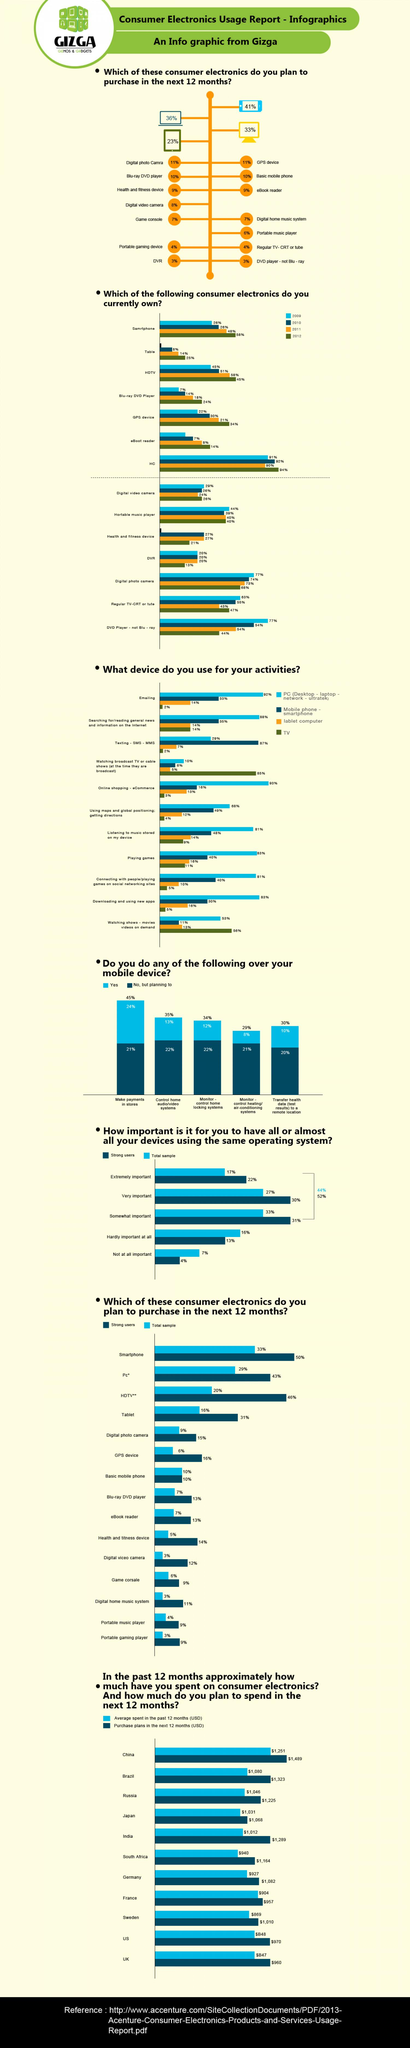Give some essential details in this illustration. According to the Consumer Electronics Usage Report from Gizga, 24% of people make payments in stores through their mobile devices. According to the report, China has the highest average spent (in USD) on consumer electronics among the given countries in the past 12 months. According to the 2012 consumer electronics usage report by Gizga, 14% of people owned an eBoot reader. According to the Consumer Electronics Usage report of Gizga in 2009, 77% of people owned a digital photo camera. According to a report, 12% of people use the monitor-control home locking system through their mobile device. 